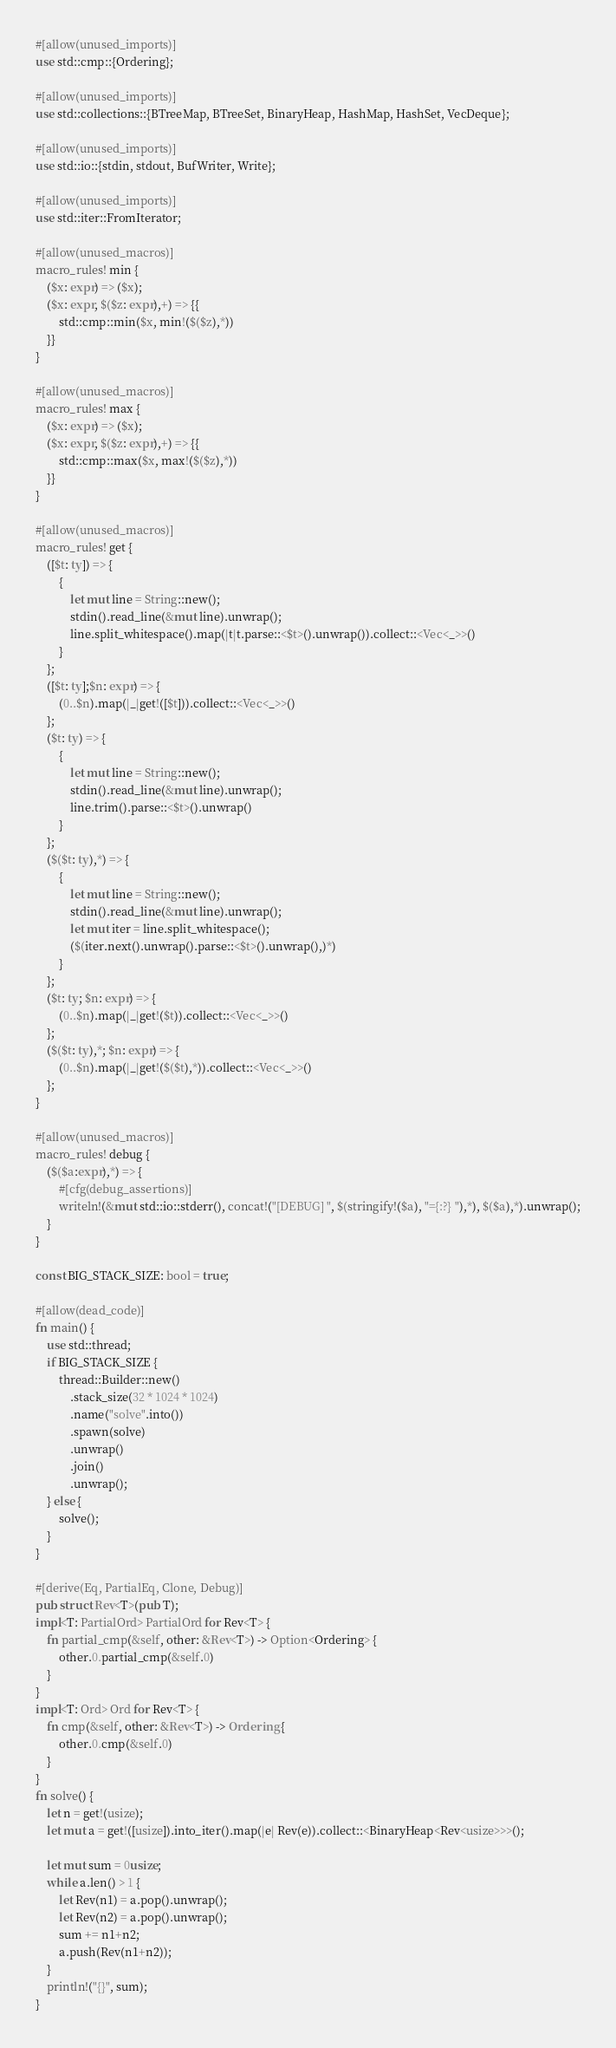Convert code to text. <code><loc_0><loc_0><loc_500><loc_500><_Rust_>#[allow(unused_imports)]
use std::cmp::{Ordering};

#[allow(unused_imports)]
use std::collections::{BTreeMap, BTreeSet, BinaryHeap, HashMap, HashSet, VecDeque};

#[allow(unused_imports)]
use std::io::{stdin, stdout, BufWriter, Write};

#[allow(unused_imports)]
use std::iter::FromIterator;

#[allow(unused_macros)]
macro_rules! min {
    ($x: expr) => ($x);
    ($x: expr, $($z: expr),+) => {{
        std::cmp::min($x, min!($($z),*))
    }}
}

#[allow(unused_macros)]
macro_rules! max {
    ($x: expr) => ($x);
    ($x: expr, $($z: expr),+) => {{
        std::cmp::max($x, max!($($z),*))
    }}
}

#[allow(unused_macros)]
macro_rules! get { 
    ([$t: ty]) => { 
        { 
            let mut line = String::new(); 
            stdin().read_line(&mut line).unwrap(); 
            line.split_whitespace().map(|t|t.parse::<$t>().unwrap()).collect::<Vec<_>>()
        }
    };
    ([$t: ty];$n: expr) => {
        (0..$n).map(|_|get!([$t])).collect::<Vec<_>>()
    };
    ($t: ty) => {
        {
            let mut line = String::new();
            stdin().read_line(&mut line).unwrap();
            line.trim().parse::<$t>().unwrap()
        }
    };
    ($($t: ty),*) => {
        { 
            let mut line = String::new();
            stdin().read_line(&mut line).unwrap();
            let mut iter = line.split_whitespace();
            ($(iter.next().unwrap().parse::<$t>().unwrap(),)*)
        }
    };
    ($t: ty; $n: expr) => {
        (0..$n).map(|_|get!($t)).collect::<Vec<_>>()
    };
    ($($t: ty),*; $n: expr) => {
        (0..$n).map(|_|get!($($t),*)).collect::<Vec<_>>()
    };
}

#[allow(unused_macros)]
macro_rules! debug {
    ($($a:expr),*) => {
        #[cfg(debug_assertions)]
        writeln!(&mut std::io::stderr(), concat!("[DEBUG] ", $(stringify!($a), "={:?} "),*), $($a),*).unwrap();
    }
}

const BIG_STACK_SIZE: bool = true;

#[allow(dead_code)]
fn main() {
    use std::thread;
    if BIG_STACK_SIZE {
        thread::Builder::new()
            .stack_size(32 * 1024 * 1024)
            .name("solve".into())
            .spawn(solve)
            .unwrap()
            .join()
            .unwrap();
    } else {
        solve();
    }
}

#[derive(Eq, PartialEq, Clone, Debug)]
pub struct Rev<T>(pub T);
impl<T: PartialOrd> PartialOrd for Rev<T> {
    fn partial_cmp(&self, other: &Rev<T>) -> Option<Ordering> {
        other.0.partial_cmp(&self.0)
    }
}
impl<T: Ord> Ord for Rev<T> {
    fn cmp(&self, other: &Rev<T>) -> Ordering {
        other.0.cmp(&self.0)
    }
}
fn solve() {
    let n = get!(usize);
    let mut a = get!([usize]).into_iter().map(|e| Rev(e)).collect::<BinaryHeap<Rev<usize>>>();
    
    let mut sum = 0usize;
    while a.len() > 1 {
        let Rev(n1) = a.pop().unwrap();
        let Rev(n2) = a.pop().unwrap();
        sum += n1+n2;
        a.push(Rev(n1+n2));
    }
    println!("{}", sum);
}
</code> 